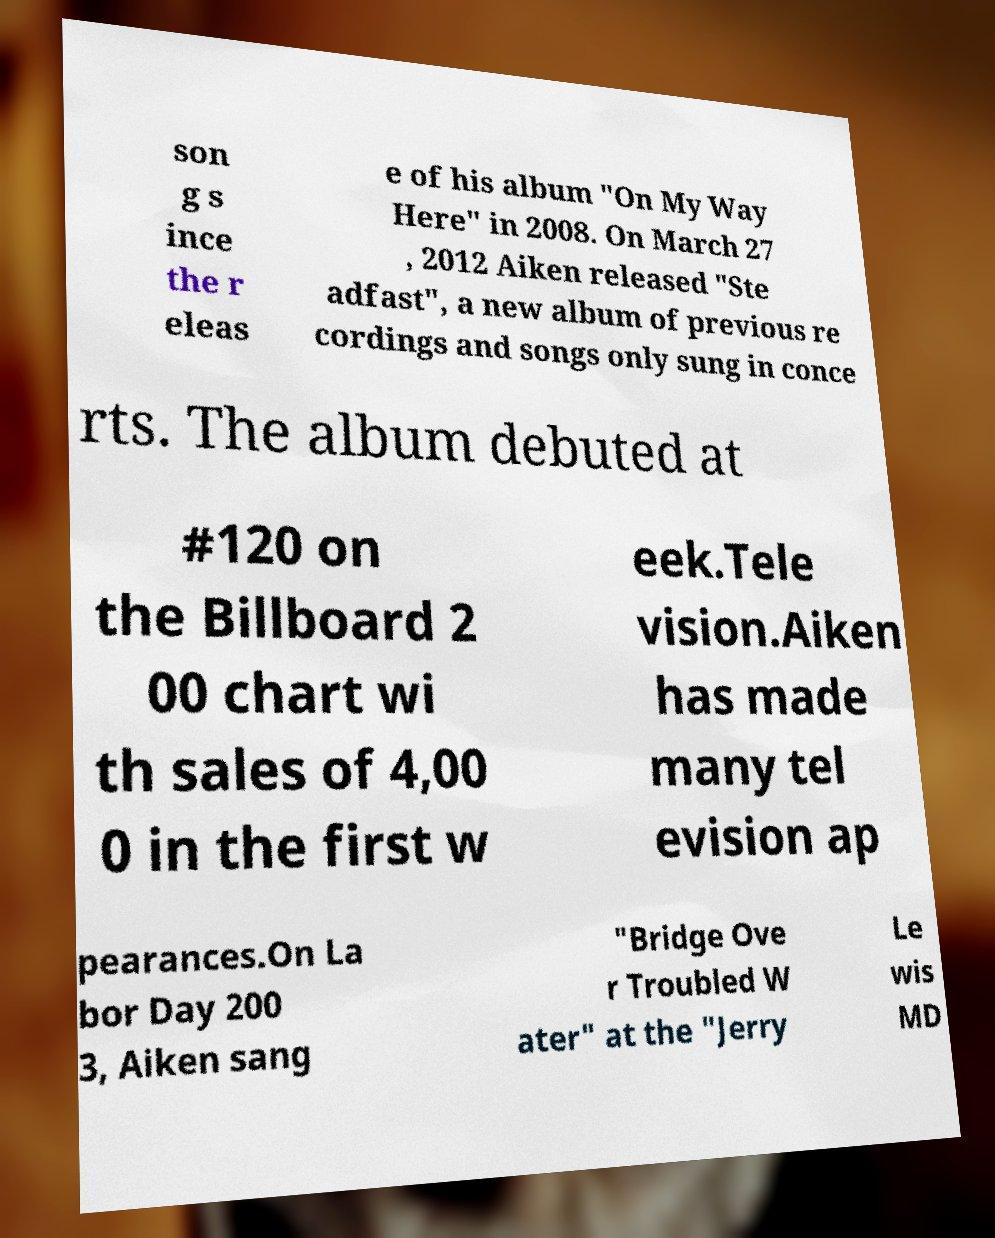Can you accurately transcribe the text from the provided image for me? son g s ince the r eleas e of his album "On My Way Here" in 2008. On March 27 , 2012 Aiken released "Ste adfast", a new album of previous re cordings and songs only sung in conce rts. The album debuted at #120 on the Billboard 2 00 chart wi th sales of 4,00 0 in the first w eek.Tele vision.Aiken has made many tel evision ap pearances.On La bor Day 200 3, Aiken sang "Bridge Ove r Troubled W ater" at the "Jerry Le wis MD 